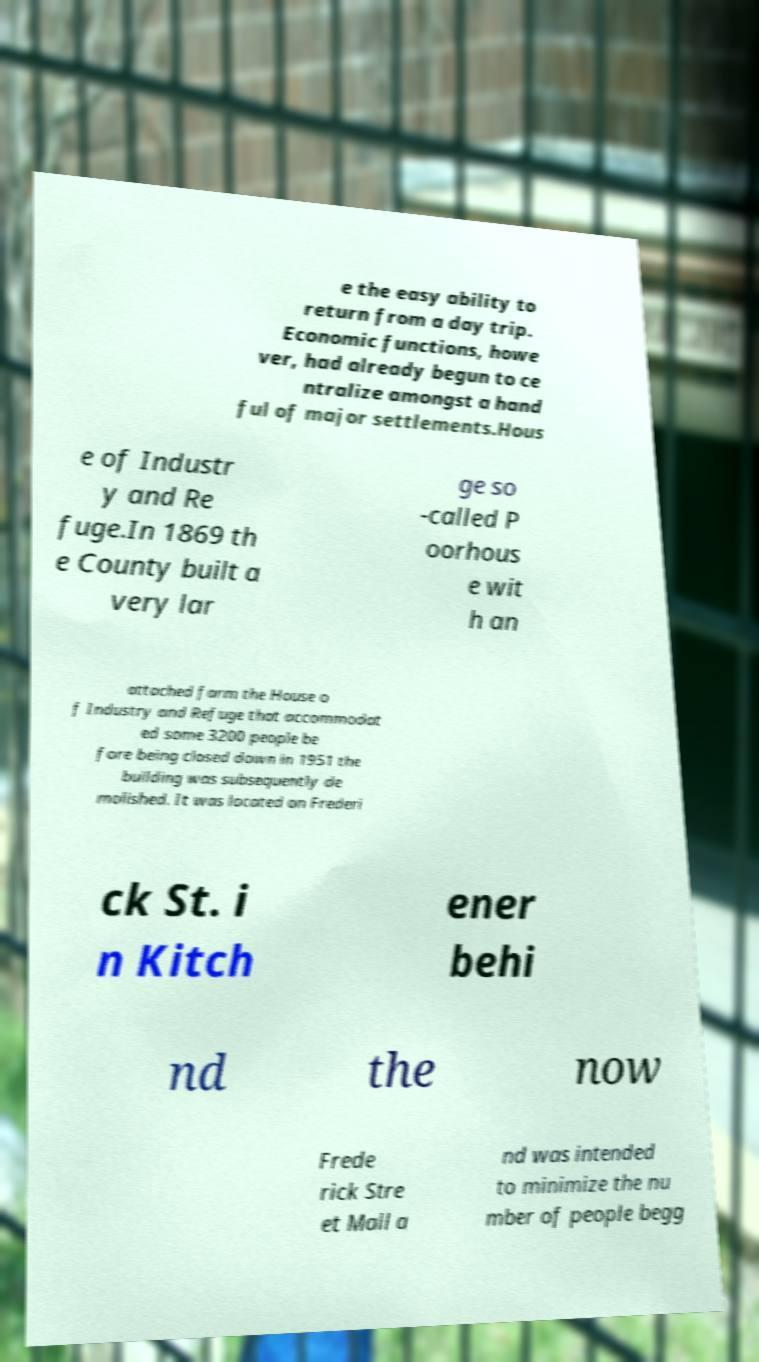Please read and relay the text visible in this image. What does it say? e the easy ability to return from a day trip. Economic functions, howe ver, had already begun to ce ntralize amongst a hand ful of major settlements.Hous e of Industr y and Re fuge.In 1869 th e County built a very lar ge so -called P oorhous e wit h an attached farm the House o f Industry and Refuge that accommodat ed some 3200 people be fore being closed down in 1951 the building was subsequently de molished. It was located on Frederi ck St. i n Kitch ener behi nd the now Frede rick Stre et Mall a nd was intended to minimize the nu mber of people begg 